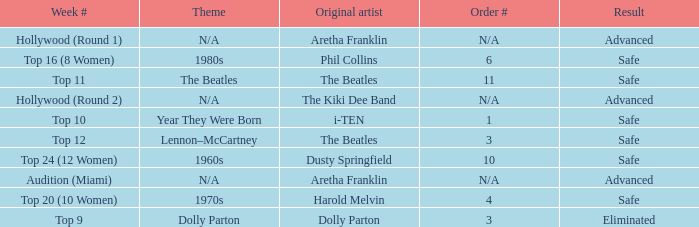What is the week number with Phil Collins as the original artist? Top 16 (8 Women). 